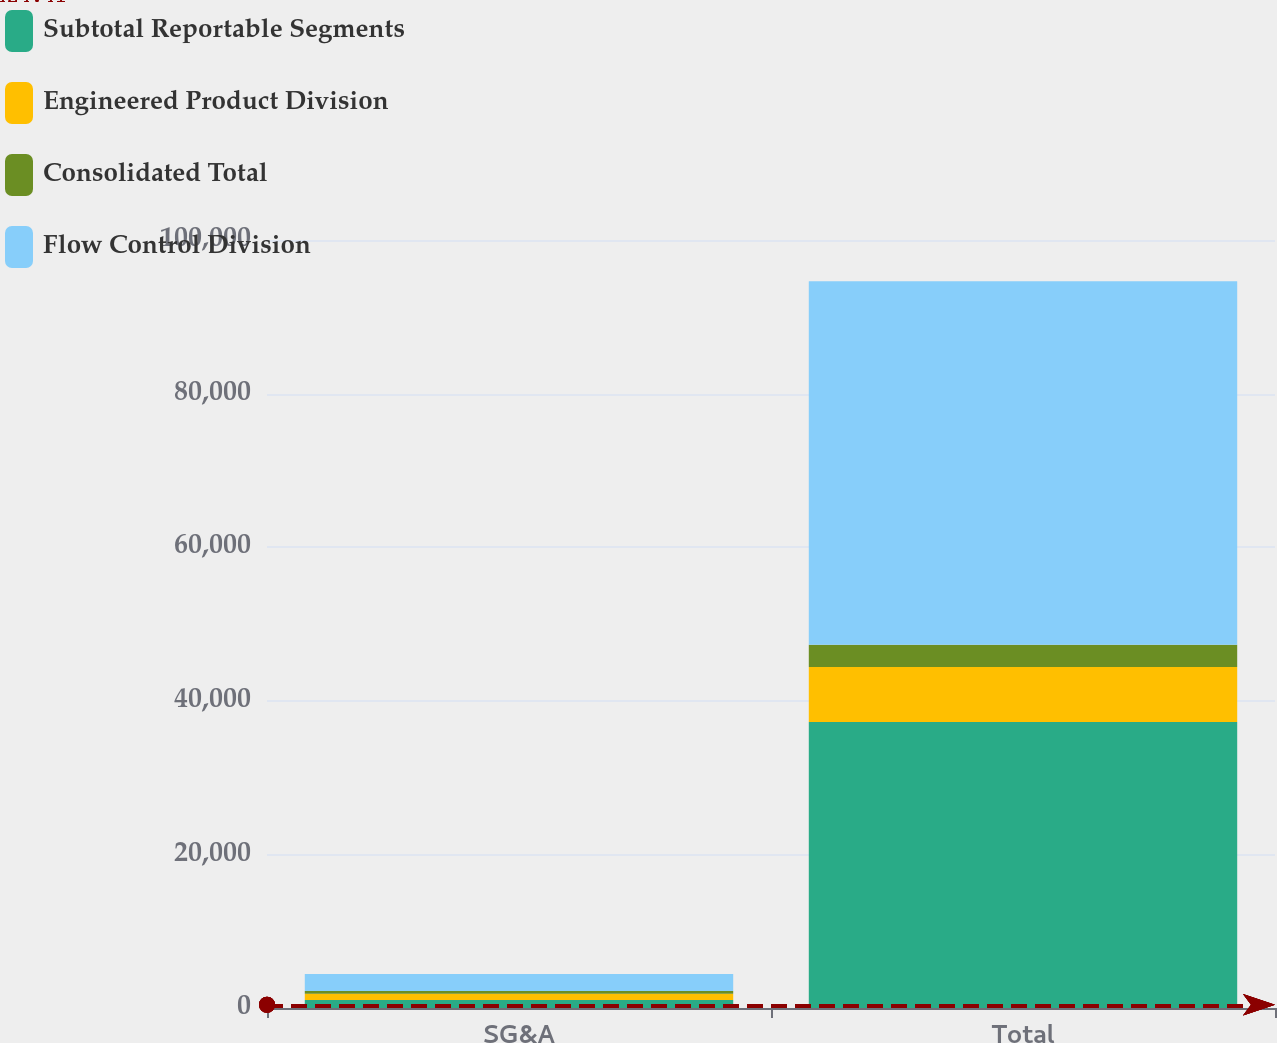Convert chart to OTSL. <chart><loc_0><loc_0><loc_500><loc_500><stacked_bar_chart><ecel><fcel>SG&A<fcel>Total<nl><fcel>Subtotal Reportable Segments<fcel>1050<fcel>37239<nl><fcel>Engineered Product Division<fcel>803<fcel>7148<nl><fcel>Consolidated Total<fcel>358<fcel>2927<nl><fcel>Flow Control Division<fcel>2211<fcel>47314<nl></chart> 